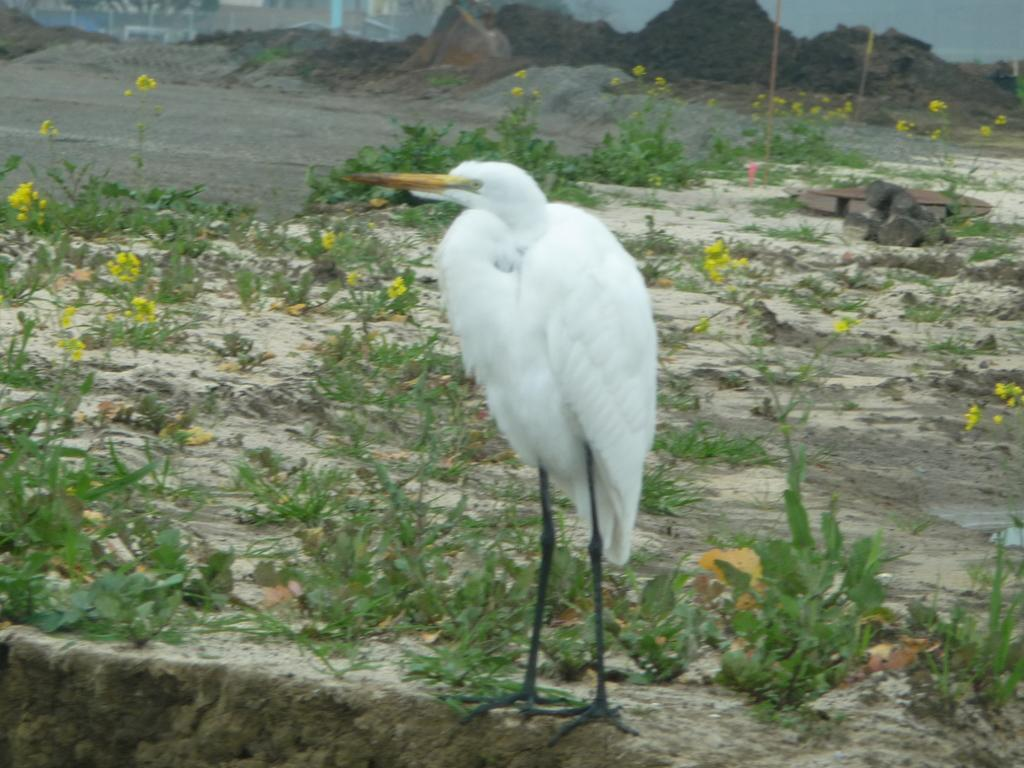What type of animal can be seen in the image? There is a bird in the image. Where is the bird located in the image? The bird is standing on the ground. What can be seen in the background of the image? There are plants, flowers, wooden logs, rocks, and some objects in the background of the image. Can you describe the stranger standing next to the bird in the image? There is no stranger present in the image; it only features a bird standing on the ground and various elements in the background. 